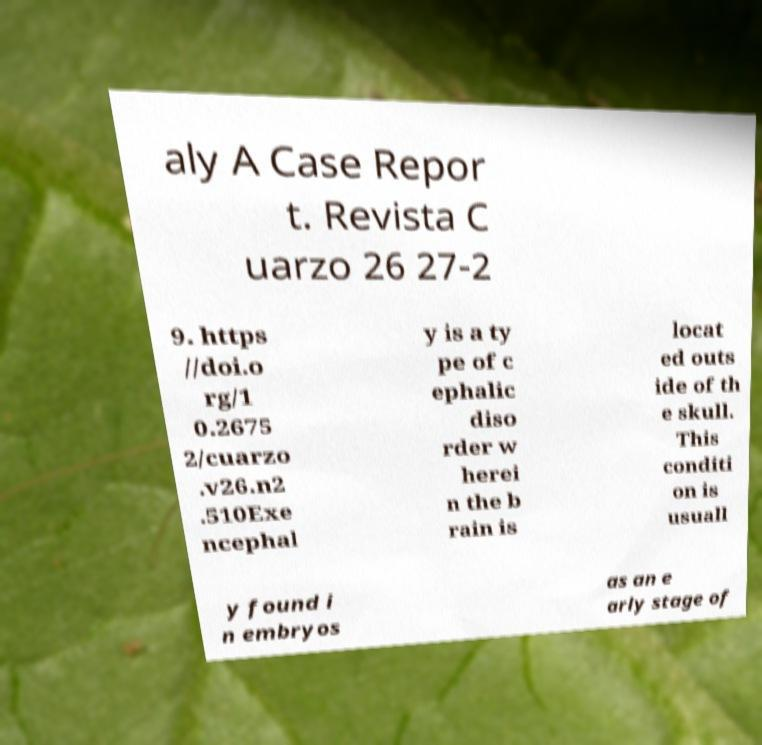Could you extract and type out the text from this image? aly A Case Repor t. Revista C uarzo 26 27-2 9. https //doi.o rg/1 0.2675 2/cuarzo .v26.n2 .510Exe ncephal y is a ty pe of c ephalic diso rder w herei n the b rain is locat ed outs ide of th e skull. This conditi on is usuall y found i n embryos as an e arly stage of 